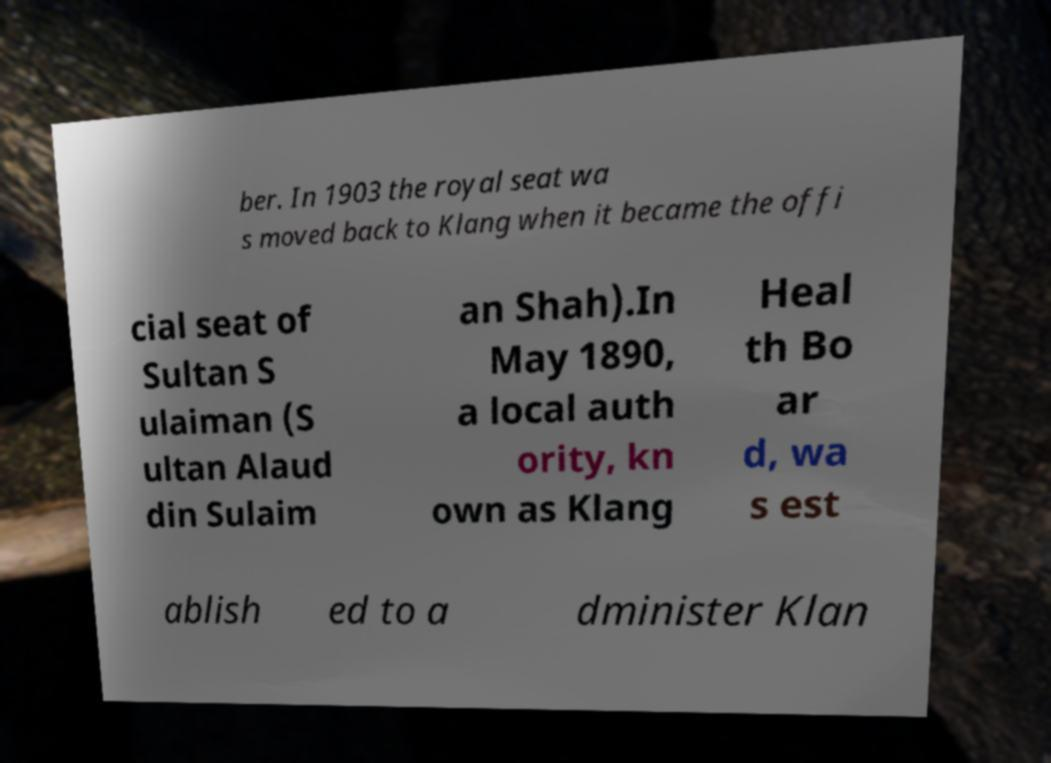Can you read and provide the text displayed in the image?This photo seems to have some interesting text. Can you extract and type it out for me? ber. In 1903 the royal seat wa s moved back to Klang when it became the offi cial seat of Sultan S ulaiman (S ultan Alaud din Sulaim an Shah).In May 1890, a local auth ority, kn own as Klang Heal th Bo ar d, wa s est ablish ed to a dminister Klan 